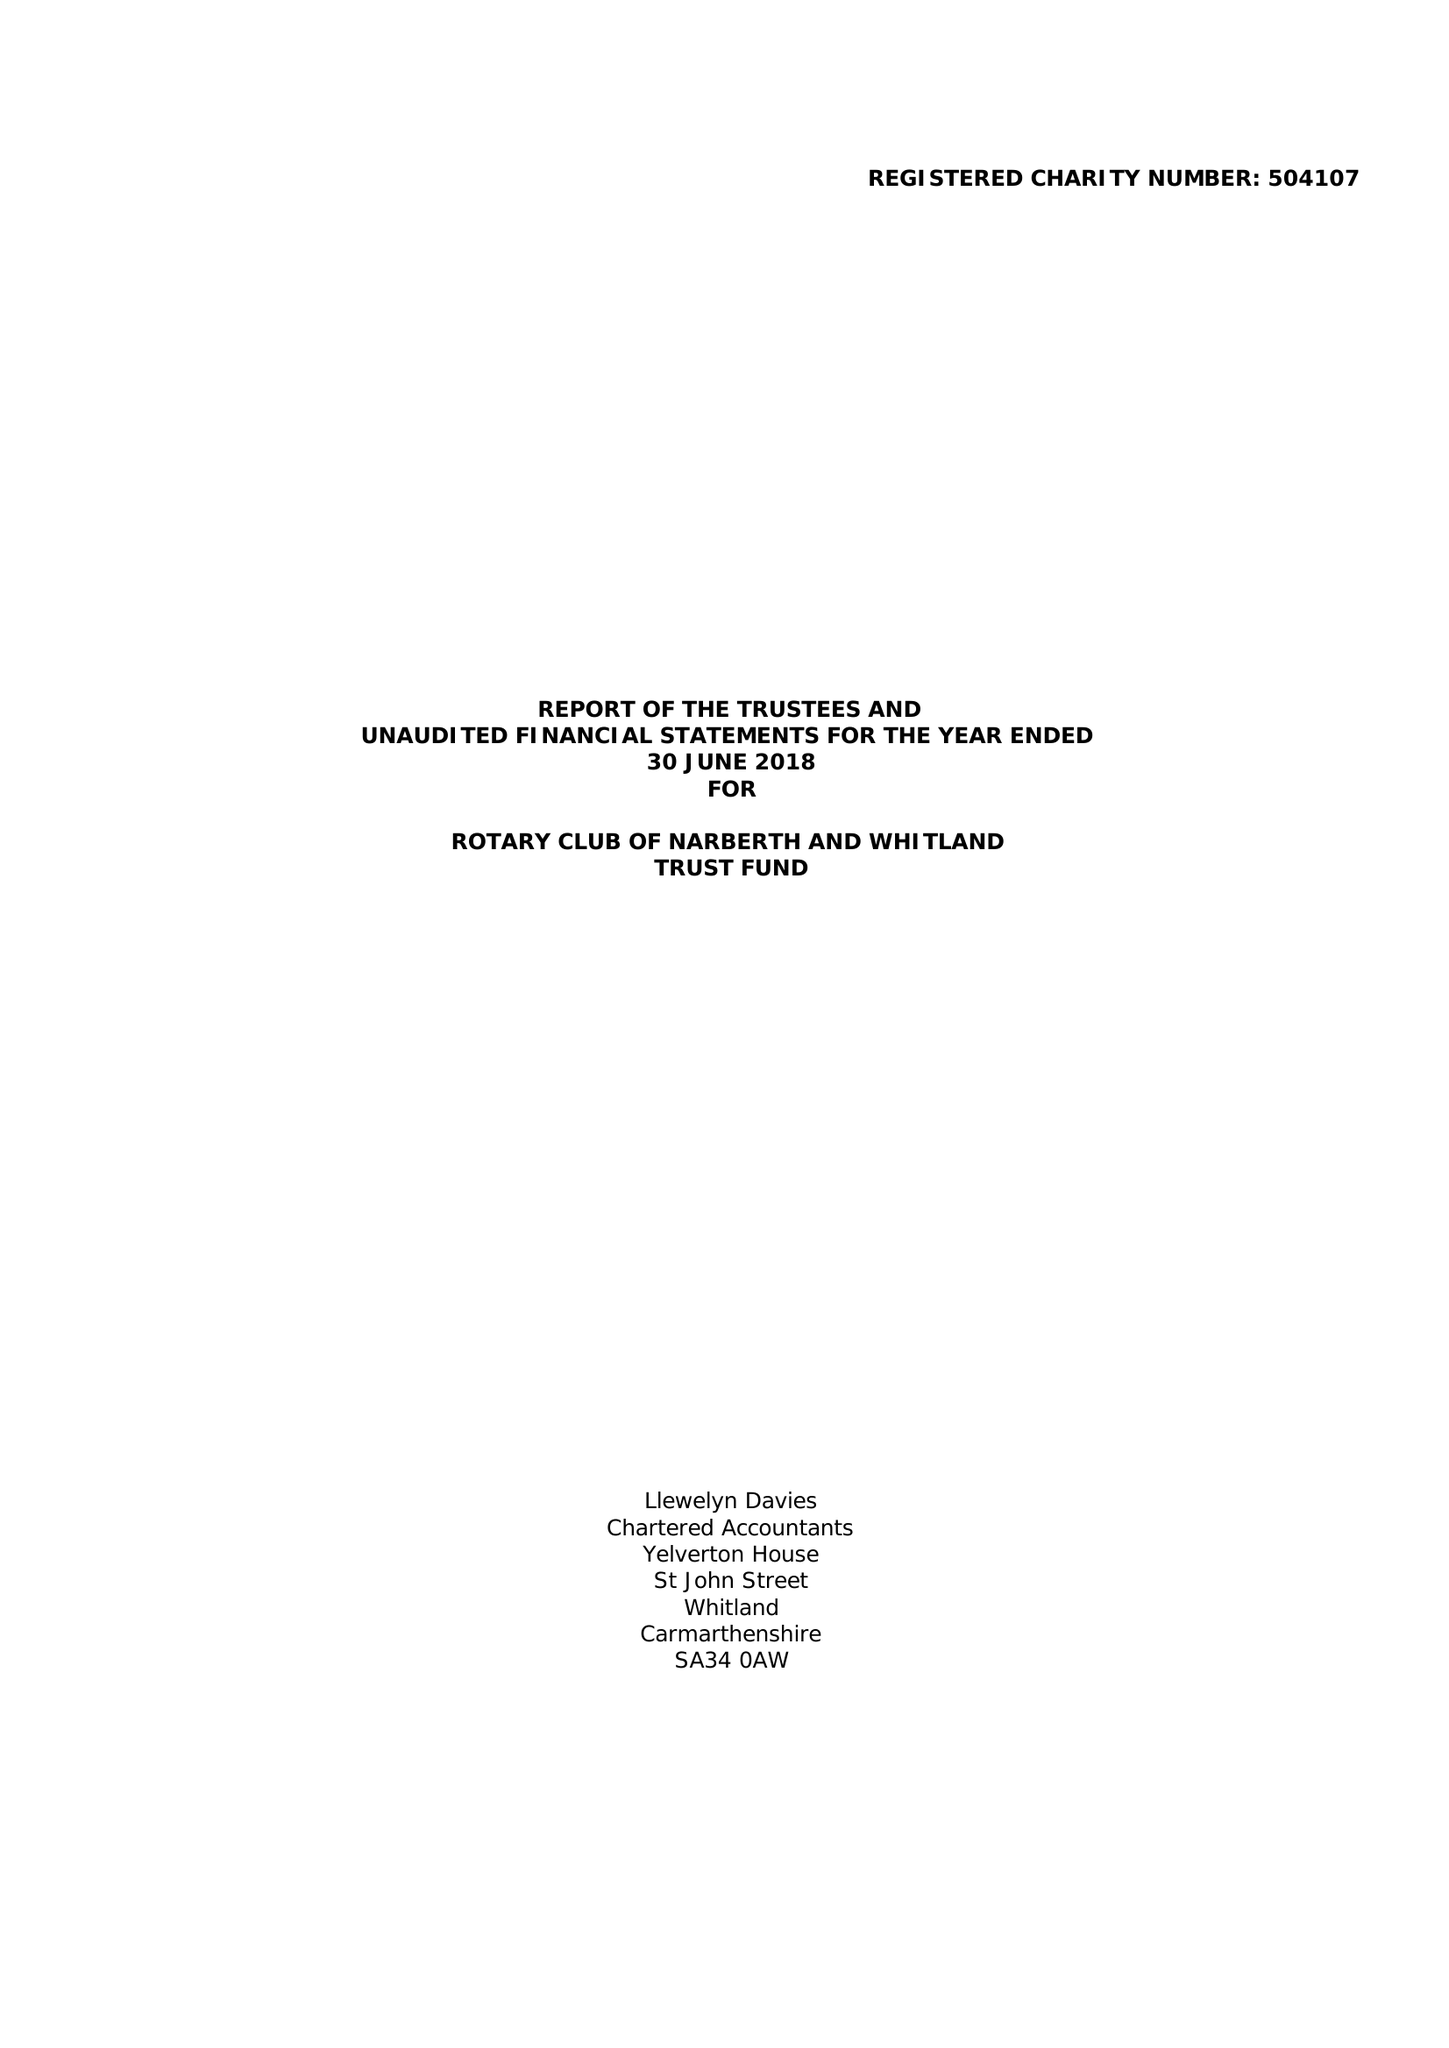What is the value for the address__street_line?
Answer the question using a single word or phrase. None 